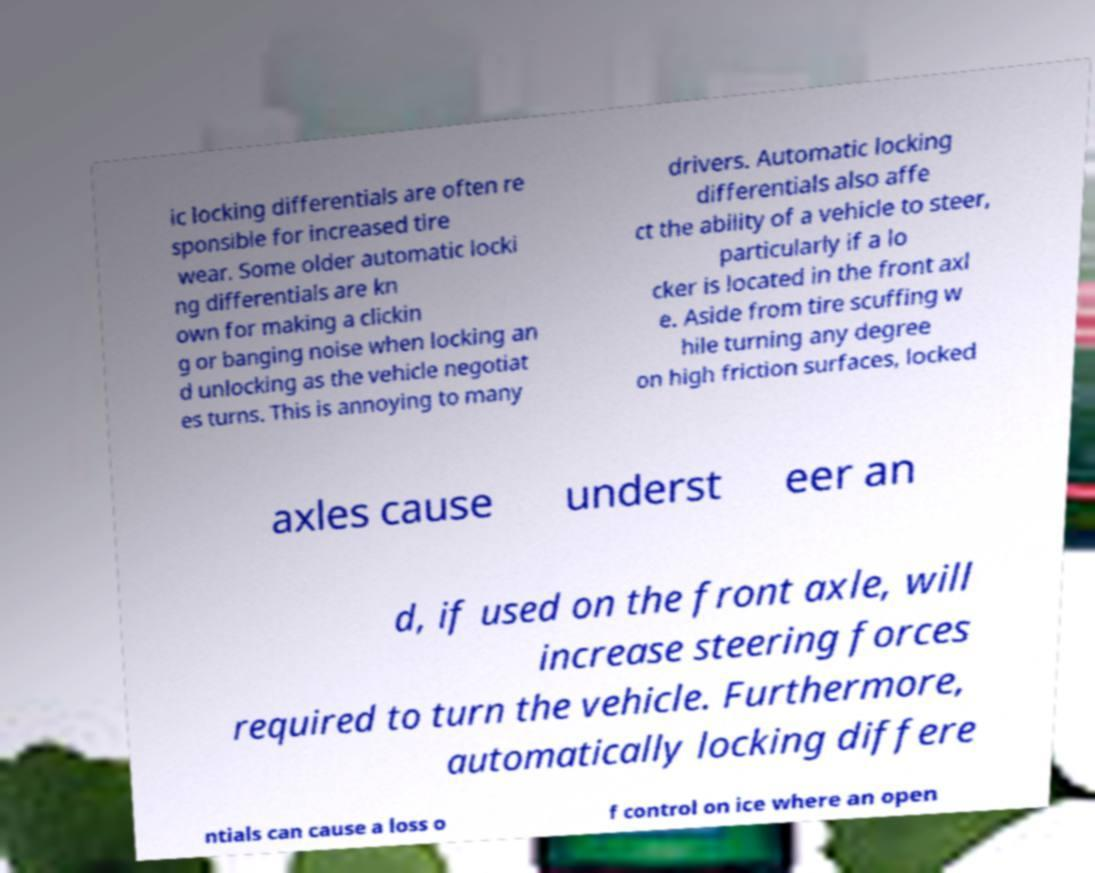There's text embedded in this image that I need extracted. Can you transcribe it verbatim? ic locking differentials are often re sponsible for increased tire wear. Some older automatic locki ng differentials are kn own for making a clickin g or banging noise when locking an d unlocking as the vehicle negotiat es turns. This is annoying to many drivers. Automatic locking differentials also affe ct the ability of a vehicle to steer, particularly if a lo cker is located in the front axl e. Aside from tire scuffing w hile turning any degree on high friction surfaces, locked axles cause underst eer an d, if used on the front axle, will increase steering forces required to turn the vehicle. Furthermore, automatically locking differe ntials can cause a loss o f control on ice where an open 